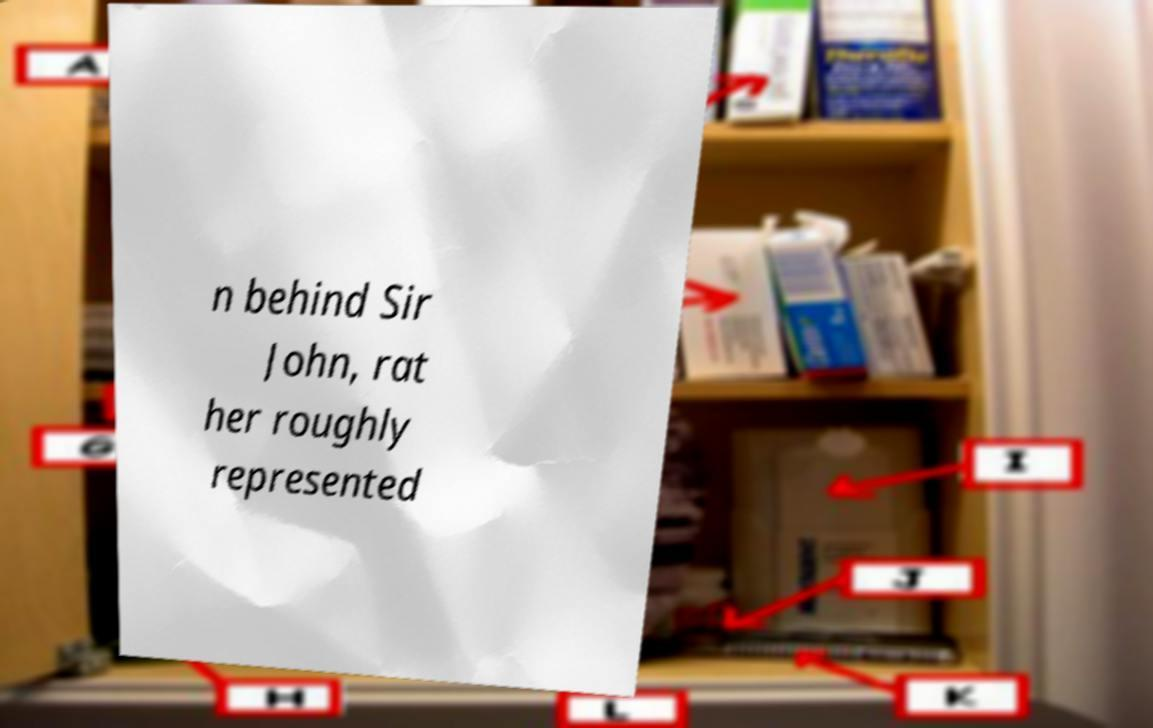There's text embedded in this image that I need extracted. Can you transcribe it verbatim? n behind Sir John, rat her roughly represented 